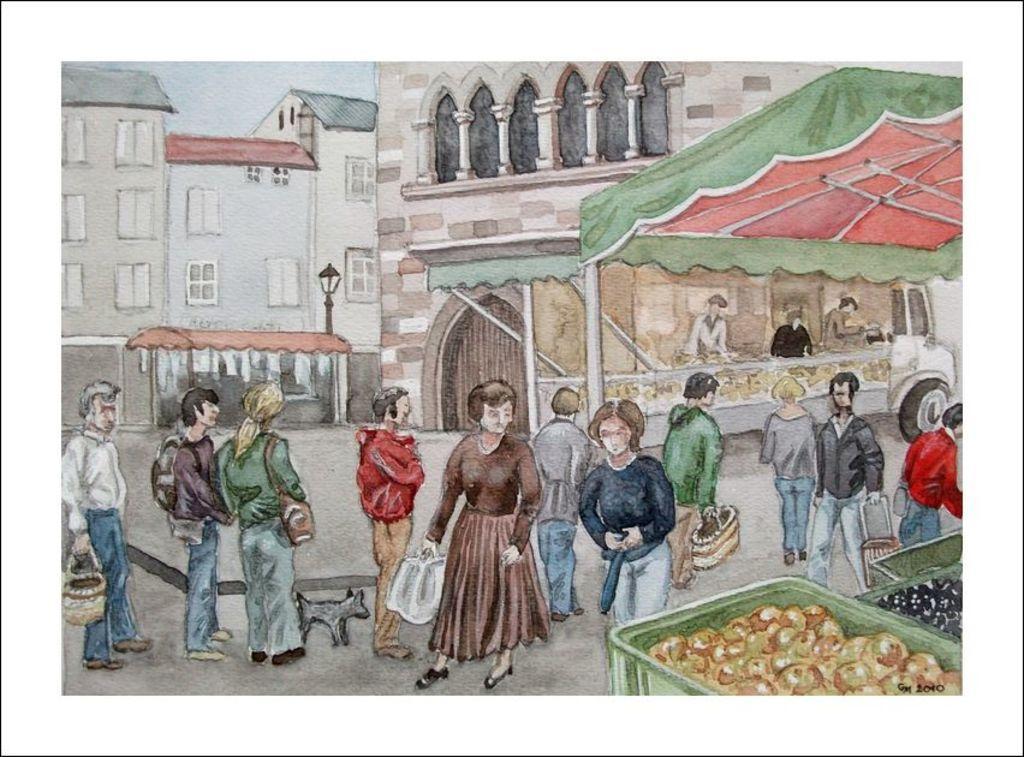Describe this image in one or two sentences. In this picture we can see tents, baskets, food items, bags, animal, buildings, windows, light pole, vehicle and a group of people on the ground and some objects. 